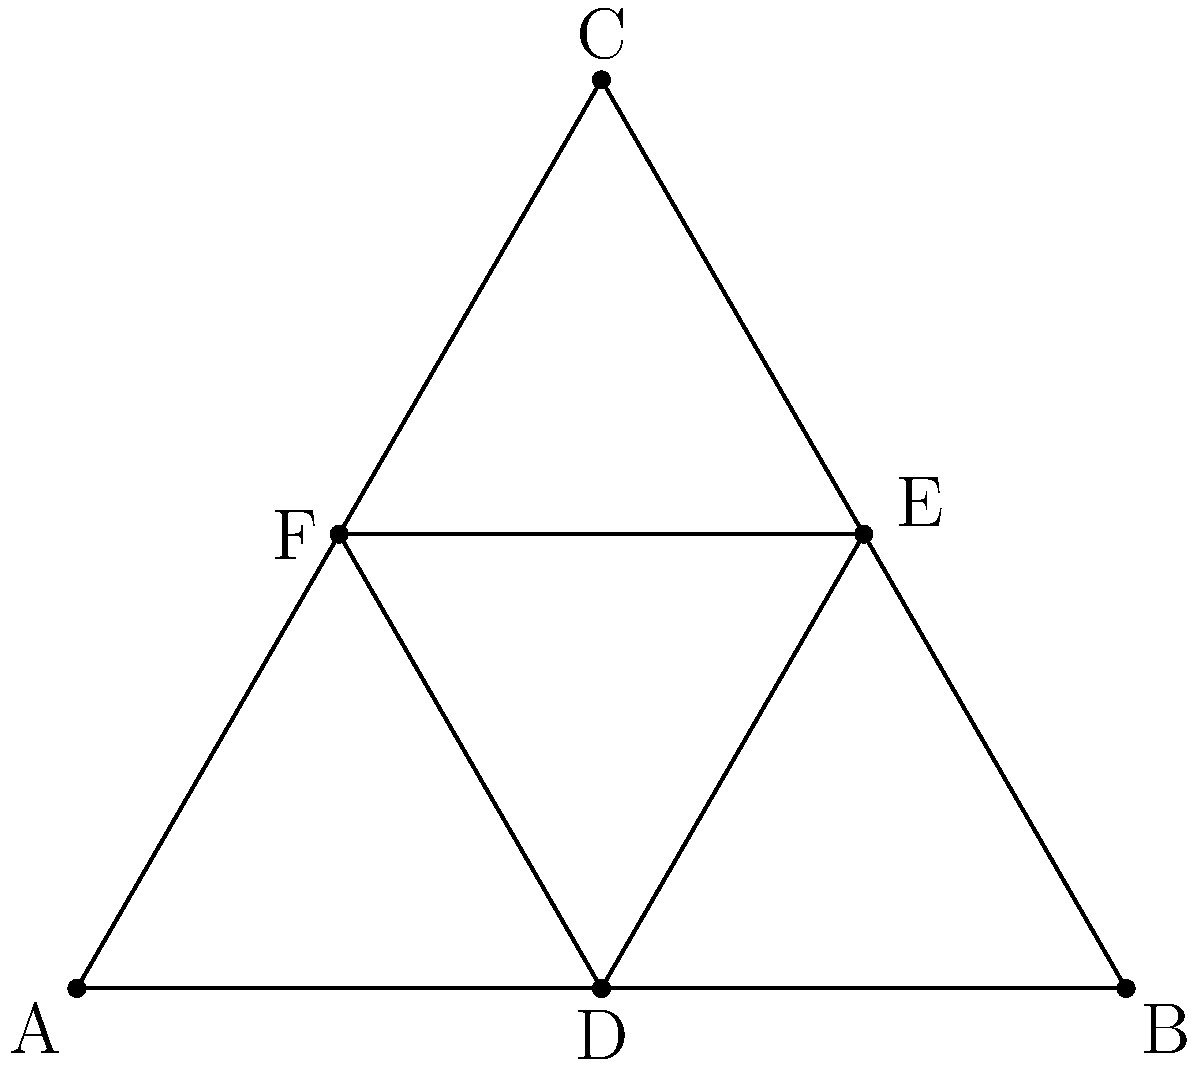In this colorful diagram of King David's star, how many different triangles can you count? Remember, God's creation is full of fascinating patterns! Let's count the triangles step-by-step, like gathering the animals for Noah's Ark:

1. First, we have the big outer triangle ABC. That's 1 triangle.

2. Then, we have the inner triangle DEF. That's another 1, so we're at 2 triangles.

3. Now, let's look at the medium-sized triangles. There are 3 of these:
   - ADF
   - BDE
   - CEF
   So now we're at 5 triangles.

4. Finally, we have the small triangles. There are 6 of these:
   - AED
   - AFE
   - BFD
   - BFE
   - CDE
   - CDF

5. Adding them all up:
   $1 + 1 + 3 + 6 = 11$

Just like Jesus had 12 disciples, this star has 11 triangles! It's amazing how God's creation can teach us about numbers and shapes.
Answer: 11 triangles 